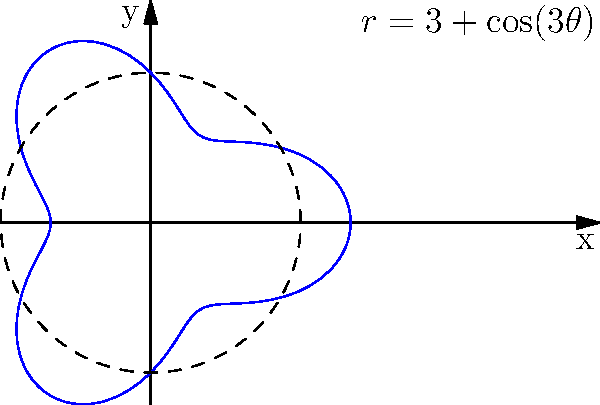You have a circular mulberry leaf patch with a radius that varies according to the polar equation $r = 3 + \cos(3\theta)$, where $r$ is measured in meters. Calculate the total area of the leaf patch in square meters. To calculate the area of the leaf patch described by the polar equation $r = 3 + \cos(3\theta)$, we need to use the formula for area in polar coordinates:

$$A = \frac{1}{2} \int_{0}^{2\pi} r^2 d\theta$$

Let's follow these steps:

1) Substitute the given equation into the area formula:
   $$A = \frac{1}{2} \int_{0}^{2\pi} (3 + \cos(3\theta))^2 d\theta$$

2) Expand the squared term:
   $$A = \frac{1}{2} \int_{0}^{2\pi} (9 + 6\cos(3\theta) + \cos^2(3\theta)) d\theta$$

3) Use the identity $\cos^2(x) = \frac{1}{2}(1 + \cos(2x))$:
   $$A = \frac{1}{2} \int_{0}^{2\pi} (9 + 6\cos(3\theta) + \frac{1}{2}(1 + \cos(6\theta))) d\theta$$

4) Simplify:
   $$A = \frac{1}{2} \int_{0}^{2\pi} (\frac{19}{2} + 6\cos(3\theta) + \frac{1}{2}\cos(6\theta)) d\theta$$

5) Integrate:
   $$A = \frac{1}{2} [\frac{19}{2}\theta + 2\sin(3\theta) + \frac{1}{12}\sin(6\theta)]_{0}^{2\pi}$$

6) Evaluate the definite integral:
   $$A = \frac{1}{2} [(\frac{19}{2} \cdot 2\pi + 0 + 0) - (0 + 0 + 0)]$$

7) Simplify:
   $$A = \frac{1}{2} \cdot \frac{19}{2} \cdot 2\pi = \frac{19\pi}{2}$$

Therefore, the total area of the leaf patch is $\frac{19\pi}{2}$ square meters.
Answer: $\frac{19\pi}{2}$ square meters 